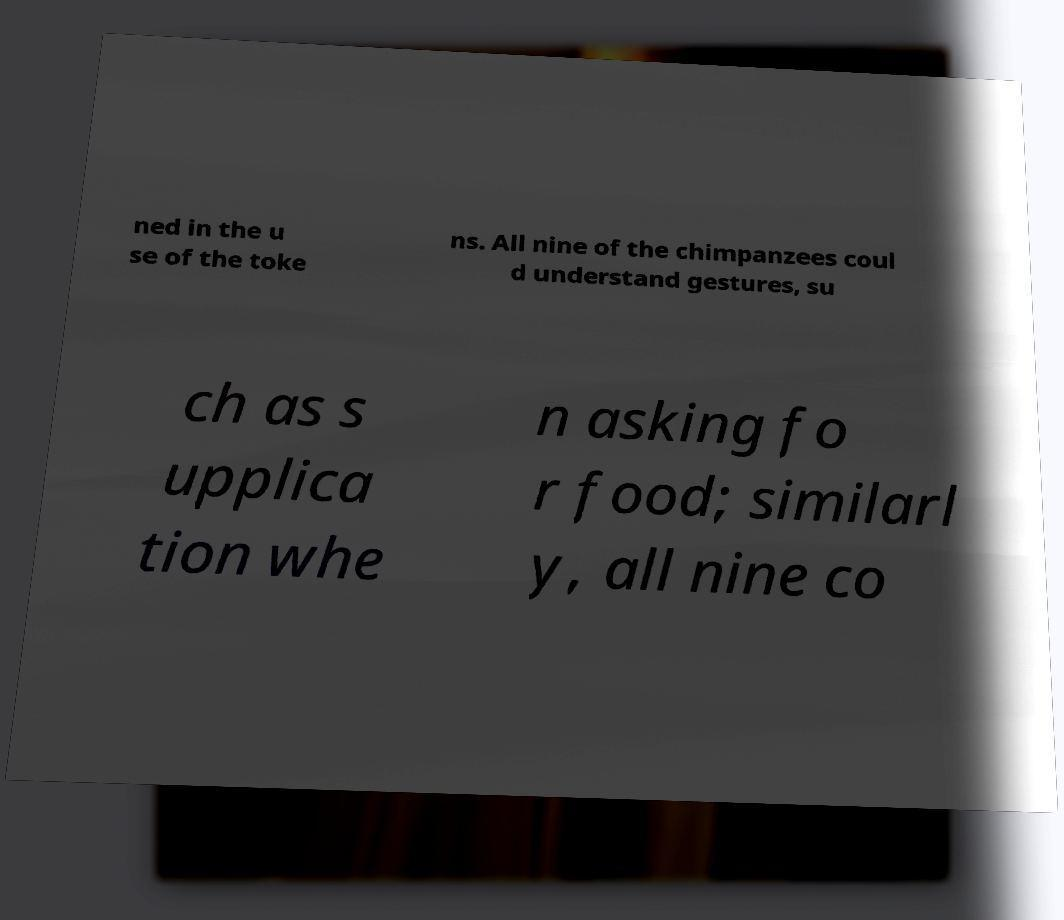There's text embedded in this image that I need extracted. Can you transcribe it verbatim? ned in the u se of the toke ns. All nine of the chimpanzees coul d understand gestures, su ch as s upplica tion whe n asking fo r food; similarl y, all nine co 